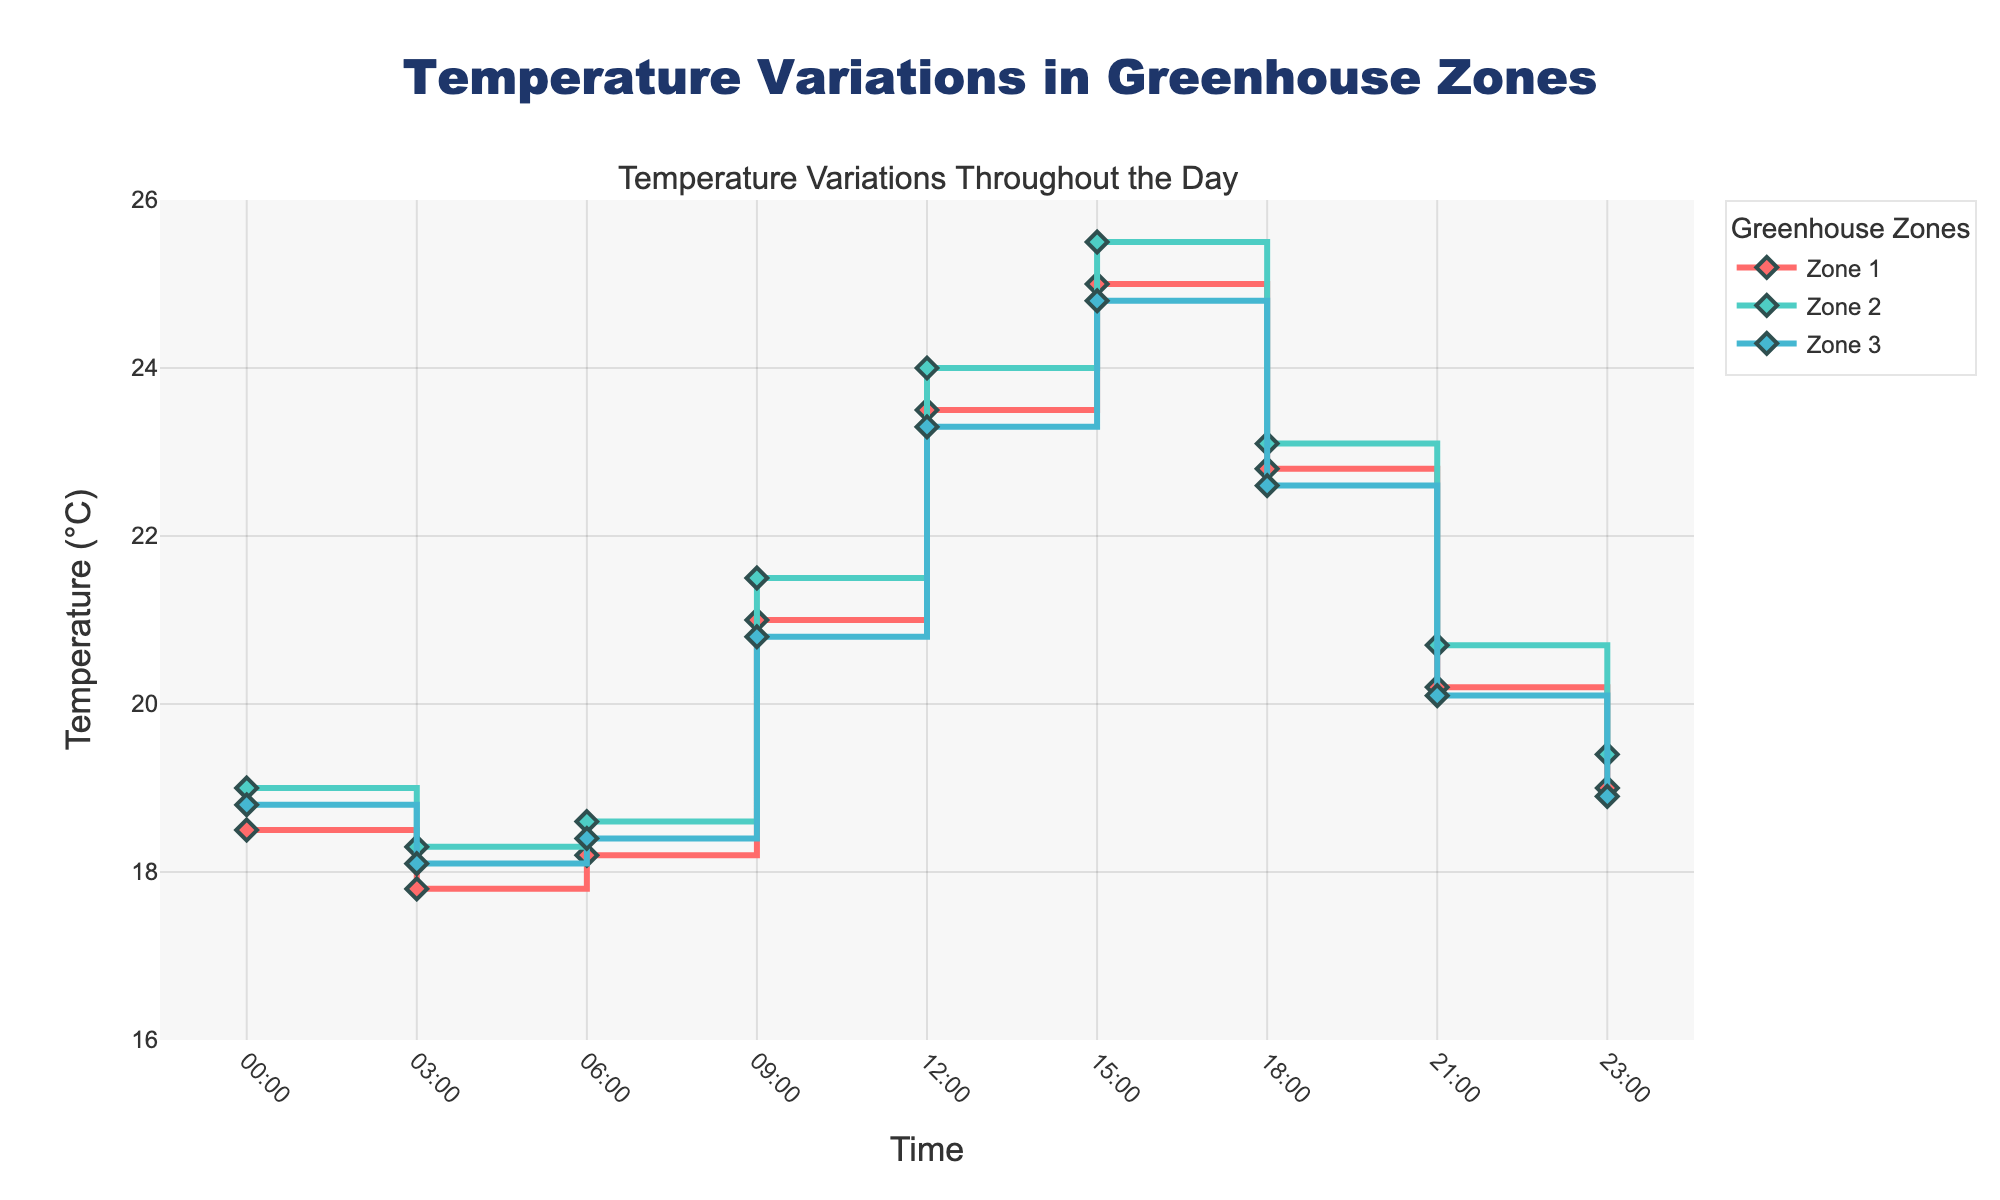What's the title of the plot? The title is displayed at the top of the figure, centered and highlighted in a larger font size.
Answer: Temperature Variations in Greenhouse Zones Which zone experiences the highest temperature and at what time? By examining the peaks of the stair lines, we see that Zone 2 reaches the highest temperature of 25.5°C at 15:00.
Answer: Zone 2 at 15:00 At what time does Zone 1 experience a noticeable temperature drop? Observe the points on the Zone 1 stair line. There is a temperature drop from 22.8°C at 18:00 to 20.2°C at 21:00, indicating a notable decrease.
Answer: Between 18:00 and 21:00 What is the difference in temperature between Zone 1 and Zone 3 at 09:00? Compare the y-values at 09:00 for both zones. Zone 1 has 21.0°C, and Zone 3 has 20.8°C. The difference is calculated by subtracting the smaller value from the larger one: 21.0 - 20.8 = 0.2°C.
Answer: 0.2°C How many times does the temperature of Zone 2 cross the 20°C mark throughout the day? Analyze the Zone 2 stair line; it stays below 20°C three times: before 09:00, towards the evening before 21:00, and slightly before 23:00. This indicates the line crosses the 20°C mark twice during the day.
Answer: 2 times Which zone has the lowest minimum temperature and what is it? Look at the lowest points of each zone's stair line; Zone 1 has the lowest minimum temperature at 17.8°C, observed at 03:00.
Answer: Zone 1 at 17.8°C Does the temperature of any zone remain constant at any time intervals? Examine all zones for flat segments in their stair lines. None of the zones have flat segments longer than a time step (from one time point to the next).
Answer: No Which zone shows the most consistent temperature change pattern throughout the day? Consistency is indicated by smoother transitions. Zone 3's stair line shows the most gradual changes without abrupt shifts, indicating a more consistent temperature change pattern.
Answer: Zone 3 